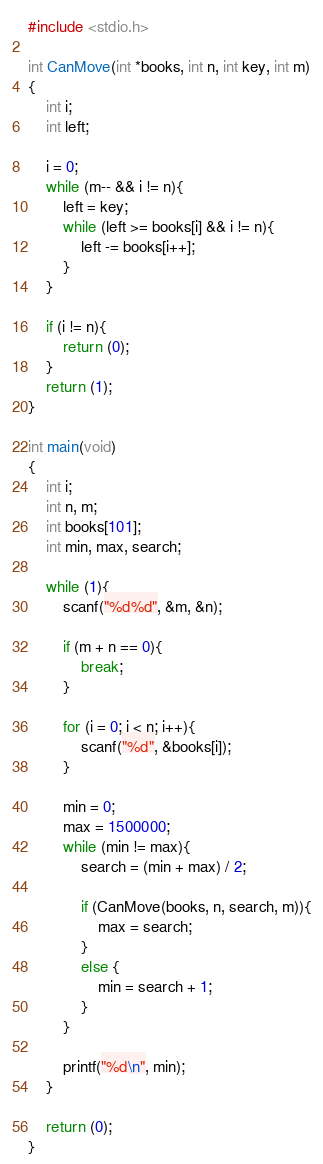<code> <loc_0><loc_0><loc_500><loc_500><_C_>#include <stdio.h>

int CanMove(int *books, int n, int key, int m)
{
    int i;
    int left;
    
    i = 0;
    while (m-- && i != n){
        left = key;
        while (left >= books[i] && i != n){
            left -= books[i++];
        }
    }
    
    if (i != n){
        return (0);
    }
    return (1);
}

int main(void)
{
    int i;
    int n, m;
    int books[101];
    int min, max, search;
    
    while (1){
        scanf("%d%d", &m, &n);
        
        if (m + n == 0){
            break;
        }
        
        for (i = 0; i < n; i++){
            scanf("%d", &books[i]);
        }
        
        min = 0;
        max = 1500000;
        while (min != max){
            search = (min + max) / 2;
            
            if (CanMove(books, n, search, m)){
                max = search;
            }
            else {
                min = search + 1;
            }
        }
        
        printf("%d\n", min);
    }
    
    return (0);
}</code> 